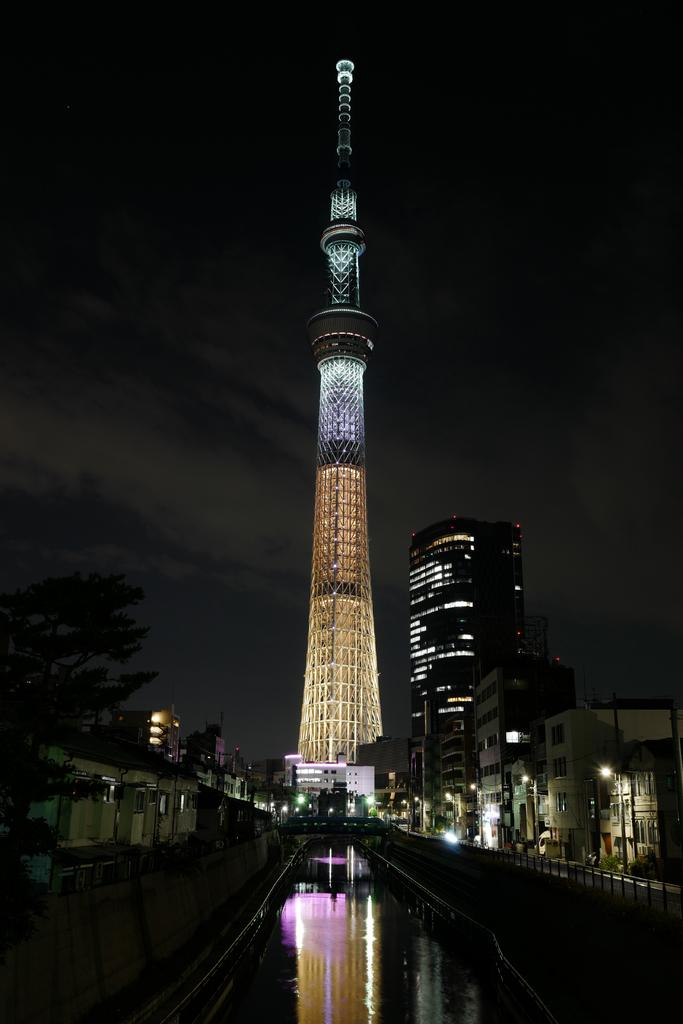What is the main structure in the image? There is a tower in the image. What type of vegetation can be seen in the image? There are trees in the image. What type of man-made structures are present in the image? There are buildings in the image. What can be seen illuminating the scene in the image? There are lights in the image. What is at the bottom of the image? There is a road at the bottom of the image. What is visible at the top of the image? The sky is visible at the top of the image. How many cars are parked next to the cent in the image? There is no cent present in the image, and therefore no cars can be parked next to it. What is the wish of the person standing near the trees in the image? There are no people visible in the image, so it is impossible to determine their wishes. 